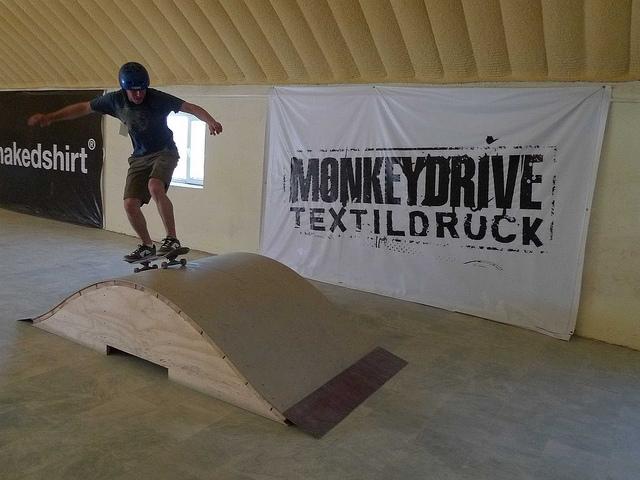What is the name of the object the man is going across?
Be succinct. Ramp. How many skaters are there?
Keep it brief. 1. Is it odd that the man is skateboarding inside?
Give a very brief answer. No. What does the sign say?
Quick response, please. Monkeydrive textildruck. What safety gear is the man wearing?
Short answer required. Helmet. 